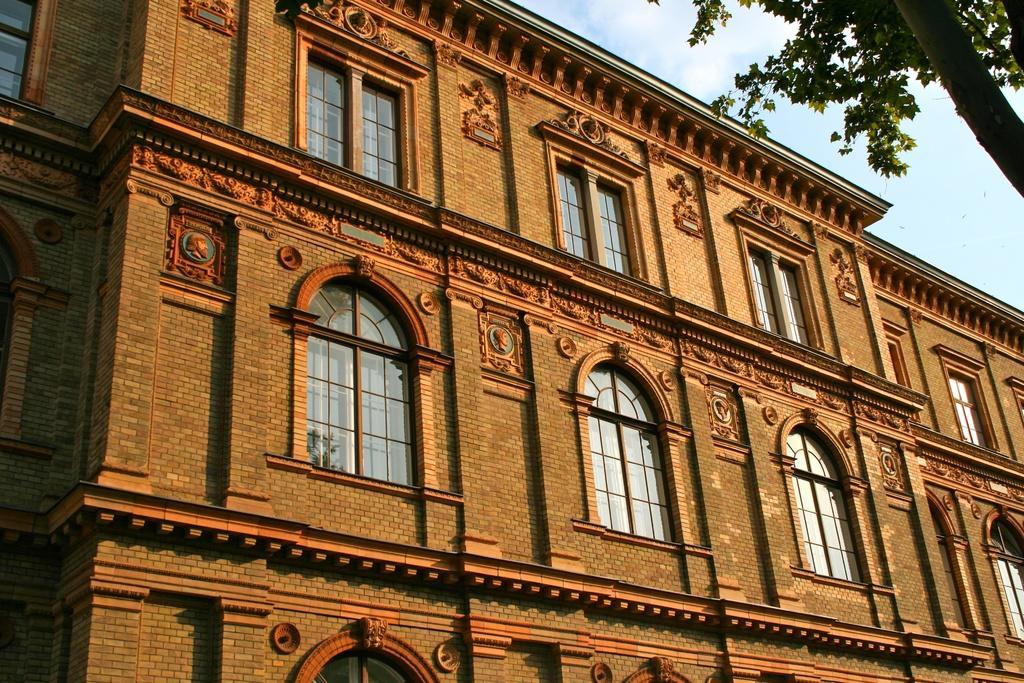In one or two sentences, can you explain what this image depicts? In this image we can see a building and it is a having many windows. There is a tree in the image. There is a sky in the image. There is a reflection of a tree on the window glass. 